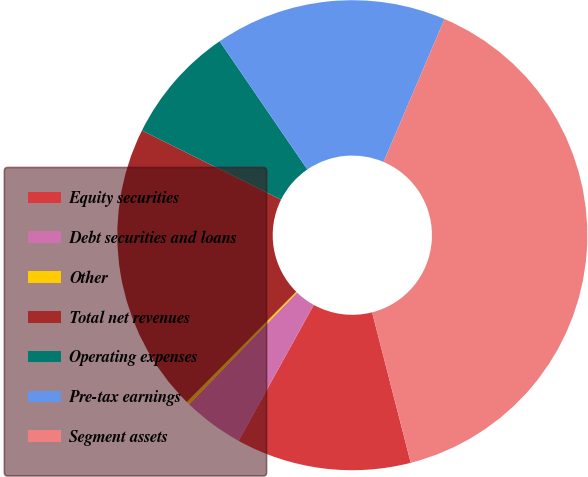Convert chart. <chart><loc_0><loc_0><loc_500><loc_500><pie_chart><fcel>Equity securities<fcel>Debt securities and loans<fcel>Other<fcel>Total net revenues<fcel>Operating expenses<fcel>Pre-tax earnings<fcel>Segment assets<nl><fcel>12.04%<fcel>4.17%<fcel>0.23%<fcel>19.91%<fcel>8.1%<fcel>15.97%<fcel>39.58%<nl></chart> 